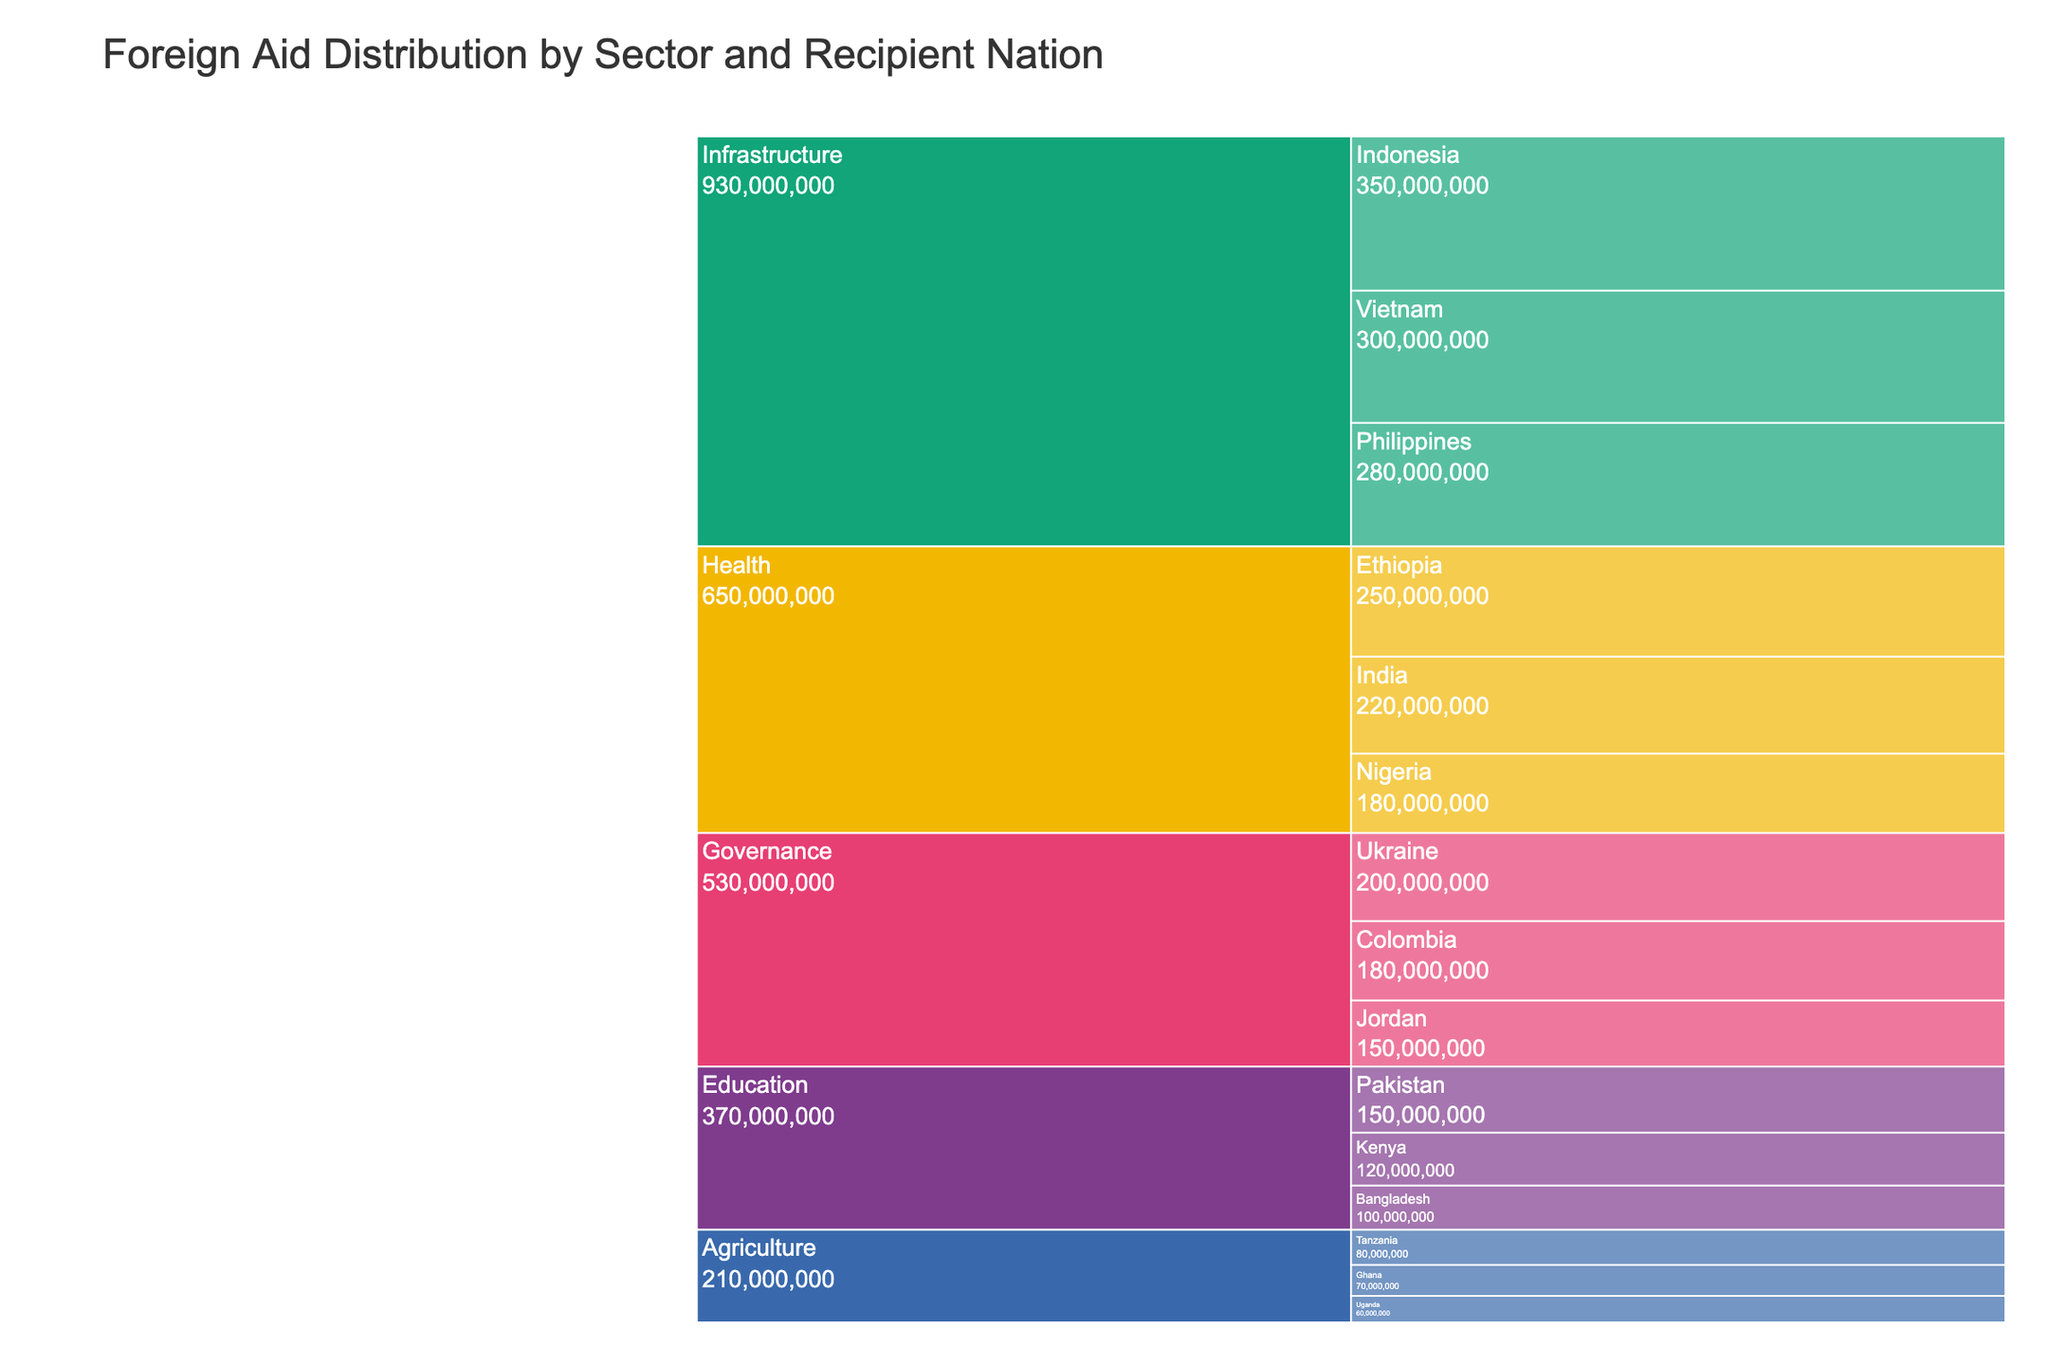What's the title of the figure? The title of the figure is usually placed at the top of the chart and clearly states the subject of the visualization.
Answer: Foreign Aid Distribution by Sector and Recipient Nation What sector received the highest total amount of foreign aid? Looking at the blocks representing each sector and summing their respective amounts, we identify the sector with the highest aggregate value. Infrastructure has the largest combined amount when observing the figure.
Answer: Infrastructure Which recipient nation in the Health sector received the most aid? By inspecting the Health sector and comparing the amounts allocated to Ethiopia, Nigeria, and India, we can determine the largest value.
Answer: Ethiopia How much total foreign aid was allocated to the Governance sector? Summing up the amounts allocated to each nation within the Governance sector (Ukraine, Colombia, Jordan), we get: $200,000,000 + $180,000,000 + $150,000,000.
Answer: $530,000,000 Which country received more aid, Kenya or Bangladesh? By comparing the aid amounts in the Education sector for Kenya ($120,000,000) and Bangladesh ($100,000,000), we determine the greater value.
Answer: Kenya What is the combined total aid amount for Infrastructure in Vietnam and Philippines? Add the amount allocated to Vietnam ($300,000,000) and the amount allocated to the Philippines ($280,000,000).
Answer: $580,000,000 What sector received the least amount of foreign aid overall? By adding the total amounts for each sector and identifying the smallest sum, we determine the sector with the least allocated aid. Agriculture sums up to be the least with ($80,000,000 + $70,000,000 + $60,000,000).
Answer: Agriculture How does the aid amount for Tanzania in Agriculture compare to Nigeria in Health? Comparing the amount for Tanzania in Agriculture ($80,000,000) against Nigeria in Health ($180,000,000), we see that Nigeria received more.
Answer: Nigeria received more Which sector has the greatest number of recipient nations? By counting the number of recipient nations listed for each sector (Health: 3, Education: 3, Infrastructure: 3, Agriculture: 3, Governance: 3), all are equal.
Answer: All sectors are equal What’s the difference in aid received between Colombia and Jordan in the Governance sector? Subtract the amount for Jordan from the amount for Colombia ($180,000,000 - $150,000,000).
Answer: $30,000,000 